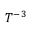<formula> <loc_0><loc_0><loc_500><loc_500>T ^ { - 3 }</formula> 